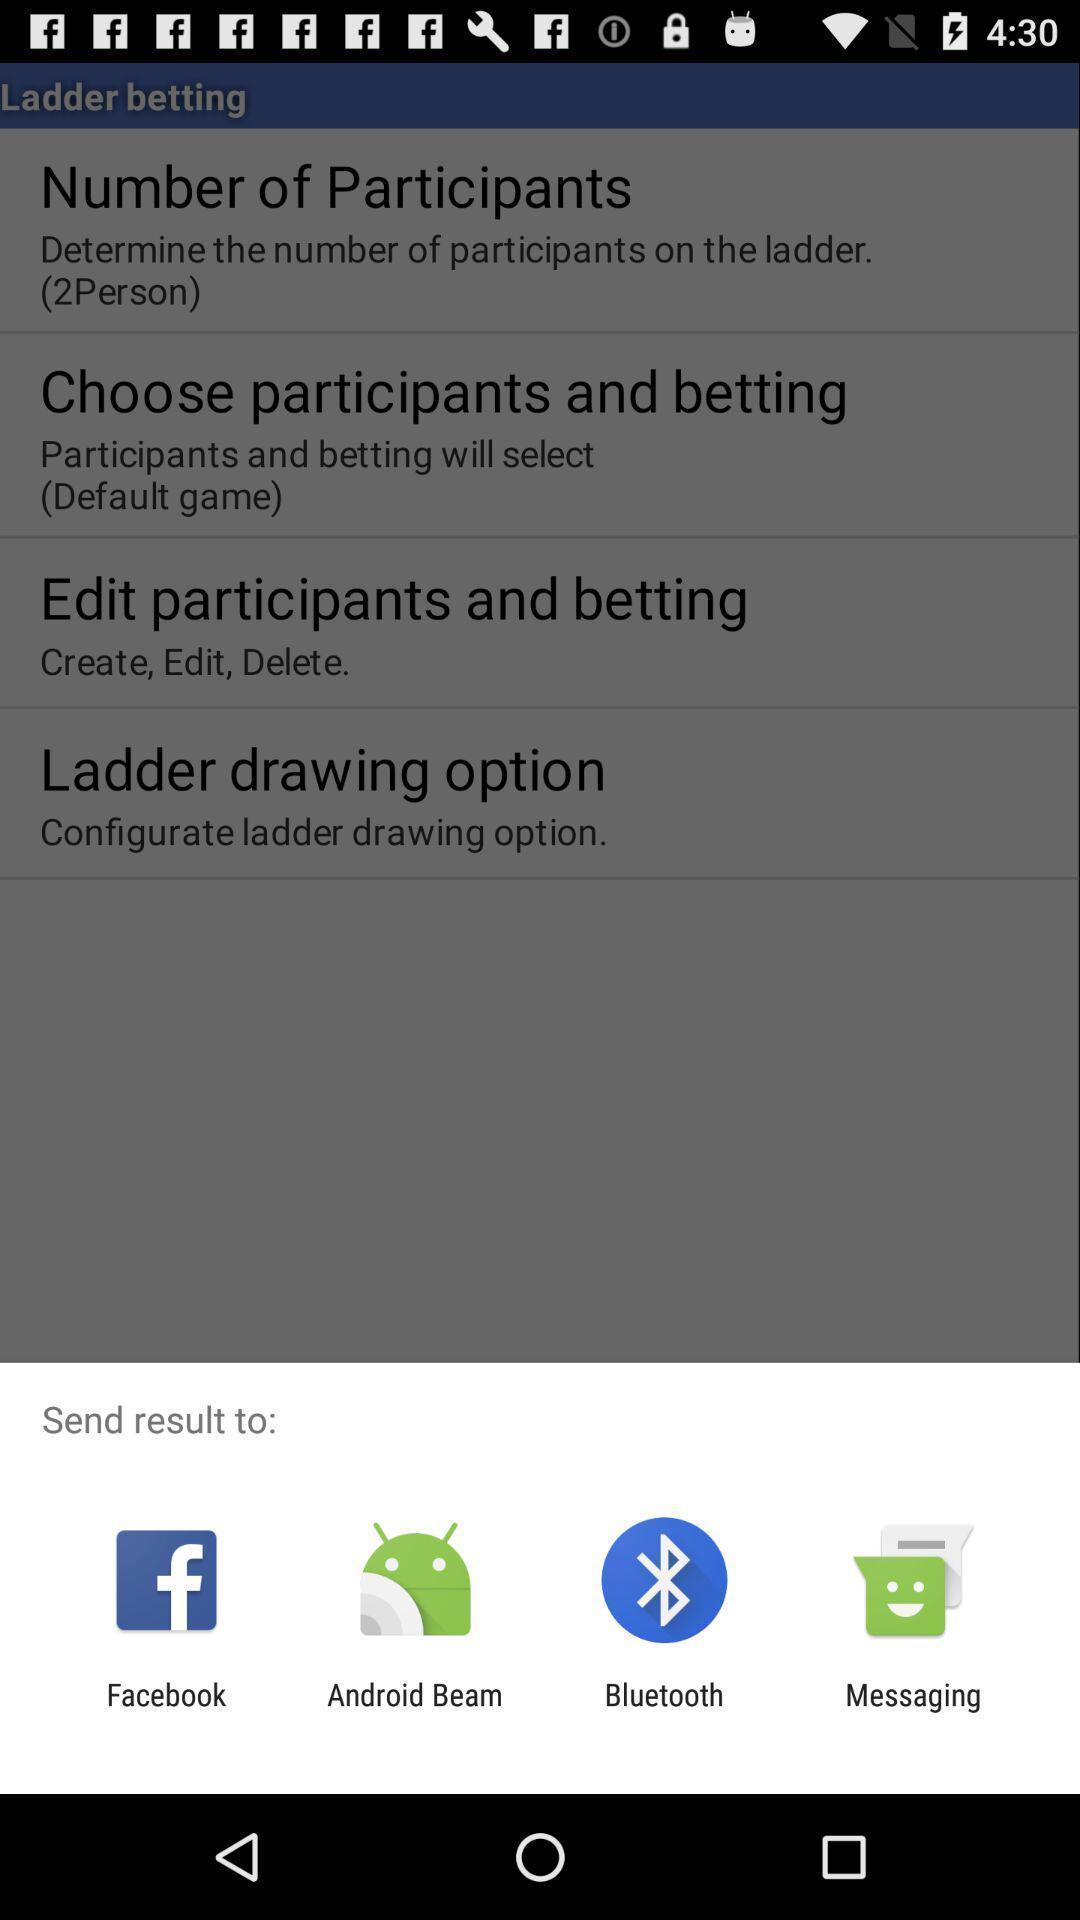Summarize the main components in this picture. Pop-up displaying various apps to send data. 